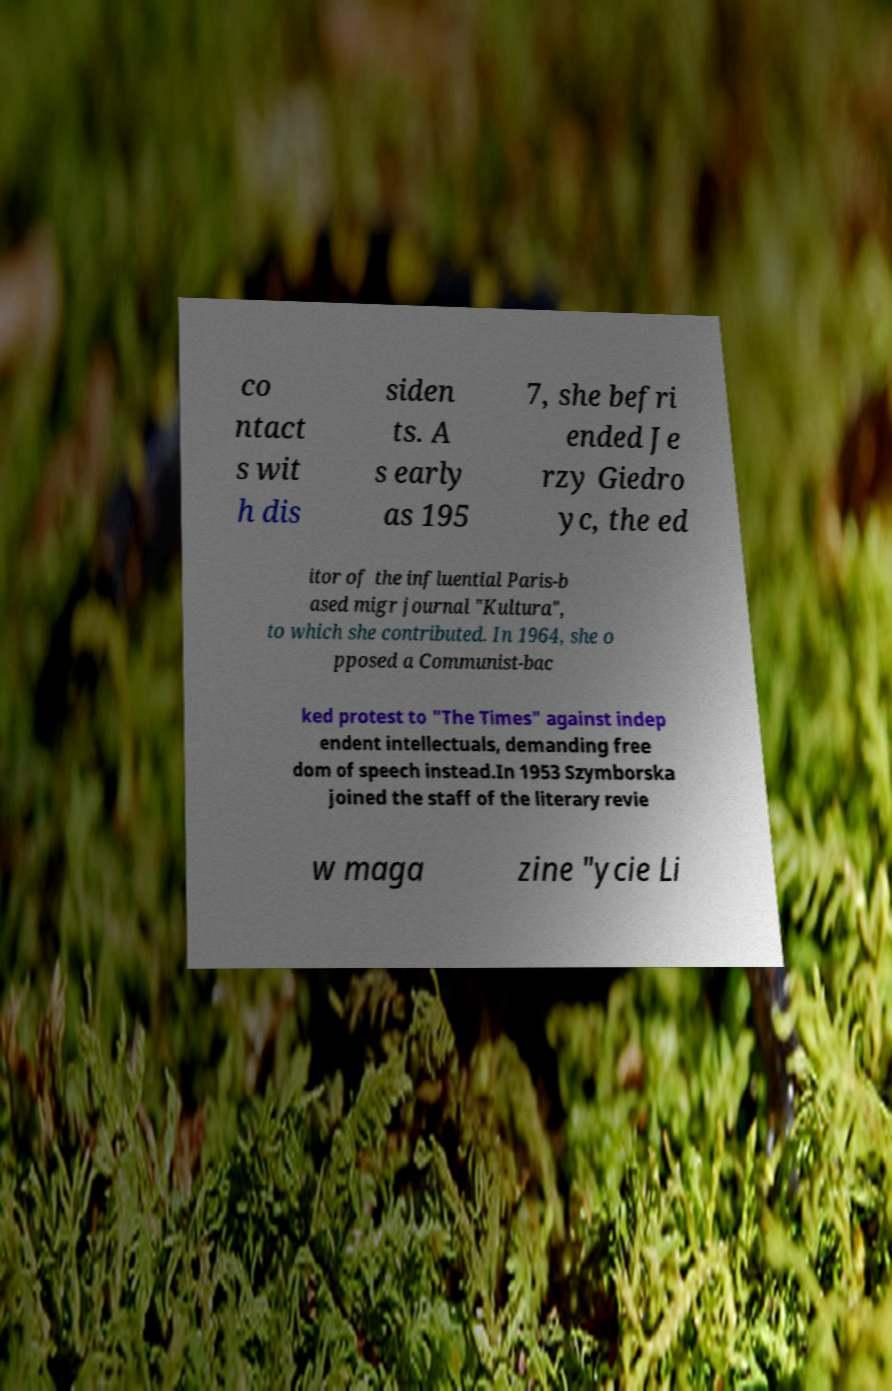Can you accurately transcribe the text from the provided image for me? co ntact s wit h dis siden ts. A s early as 195 7, she befri ended Je rzy Giedro yc, the ed itor of the influential Paris-b ased migr journal "Kultura", to which she contributed. In 1964, she o pposed a Communist-bac ked protest to "The Times" against indep endent intellectuals, demanding free dom of speech instead.In 1953 Szymborska joined the staff of the literary revie w maga zine "ycie Li 